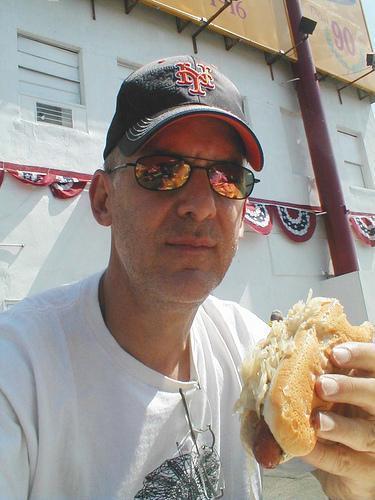How many hotdogs is he eating?
Give a very brief answer. 1. 